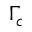Convert formula to latex. <formula><loc_0><loc_0><loc_500><loc_500>\Gamma _ { c }</formula> 